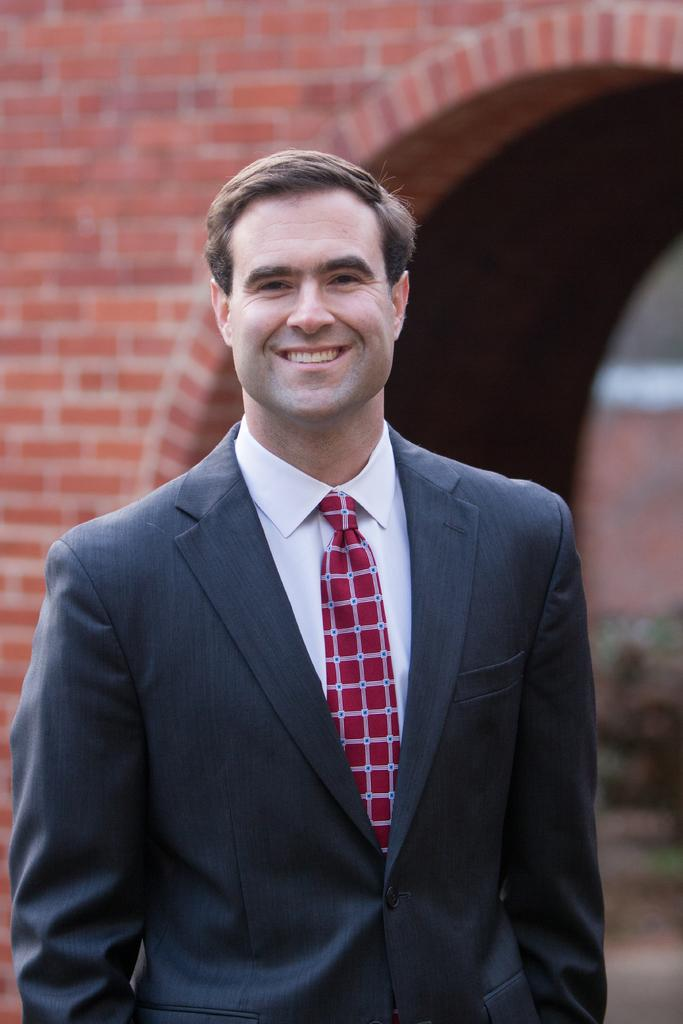What is the person in the image doing? The person is standing in the image. What expression does the person have? The person is smiling. What type of clothing is the person wearing? The person is wearing a suit. What can be seen in the background of the image? There is a brick wall in the background of the image. What type of steel is used to construct the current in the image? There is no steel or current present in the image; it features a person standing and smiling while wearing a suit, with a brick wall in the background. 